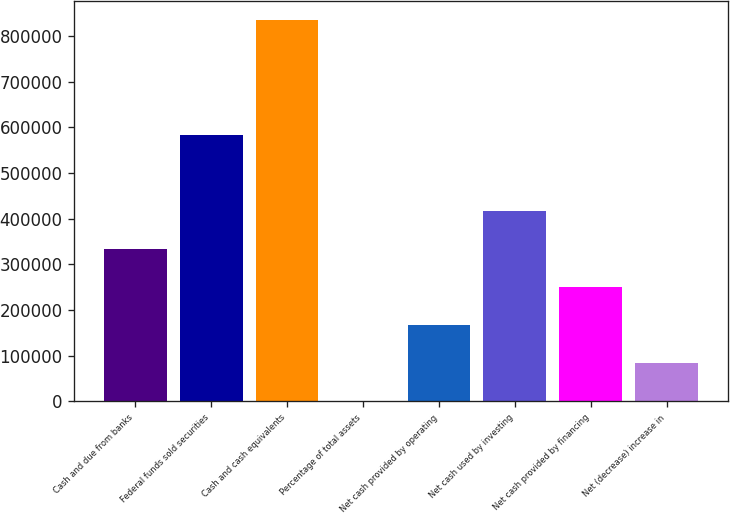Convert chart. <chart><loc_0><loc_0><loc_500><loc_500><bar_chart><fcel>Cash and due from banks<fcel>Federal funds sold securities<fcel>Cash and cash equivalents<fcel>Percentage of total assets<fcel>Net cash provided by operating<fcel>Net cash used by investing<fcel>Net cash provided by financing<fcel>Net (decrease) increase in<nl><fcel>334136<fcel>582792<fcel>835313<fcel>18.7<fcel>167078<fcel>417666<fcel>250607<fcel>83548.1<nl></chart> 